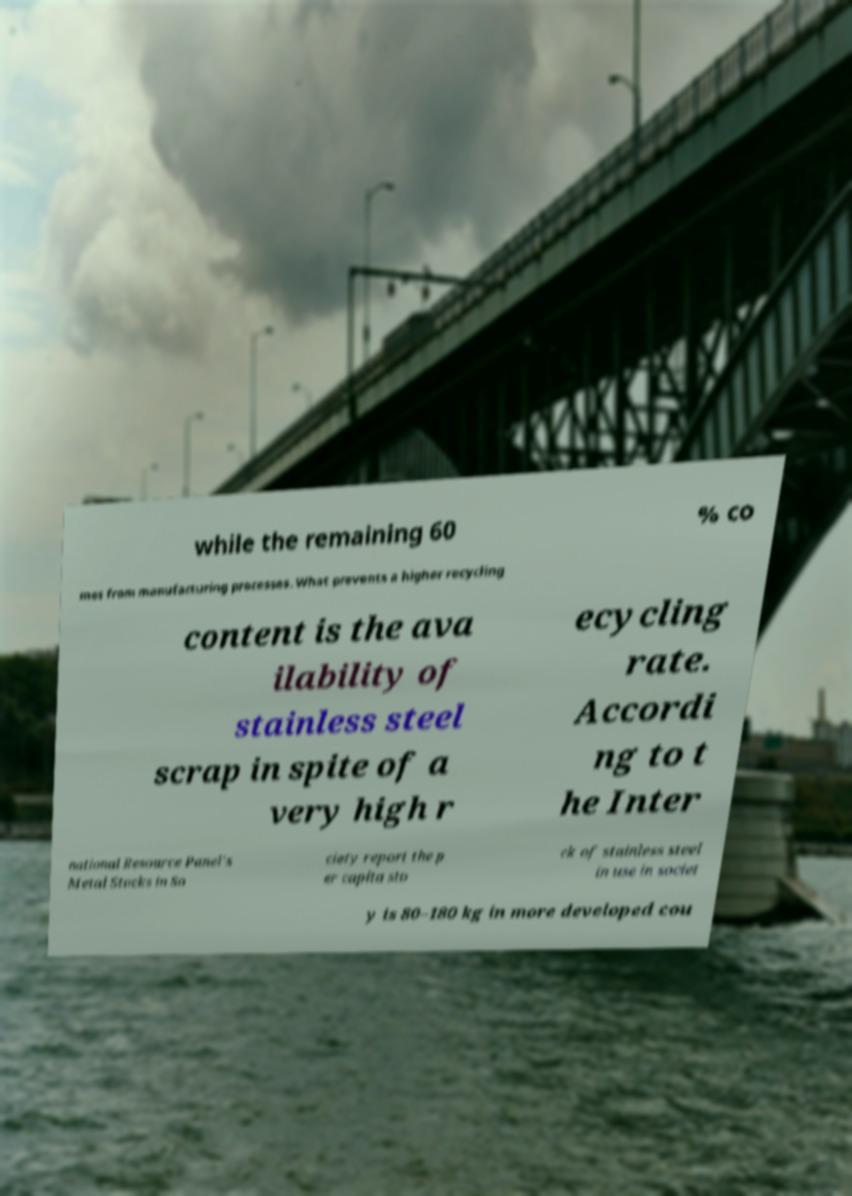Can you accurately transcribe the text from the provided image for me? while the remaining 60 % co mes from manufacturing processes. What prevents a higher recycling content is the ava ilability of stainless steel scrap in spite of a very high r ecycling rate. Accordi ng to t he Inter national Resource Panel's Metal Stocks in So ciety report the p er capita sto ck of stainless steel in use in societ y is 80–180 kg in more developed cou 